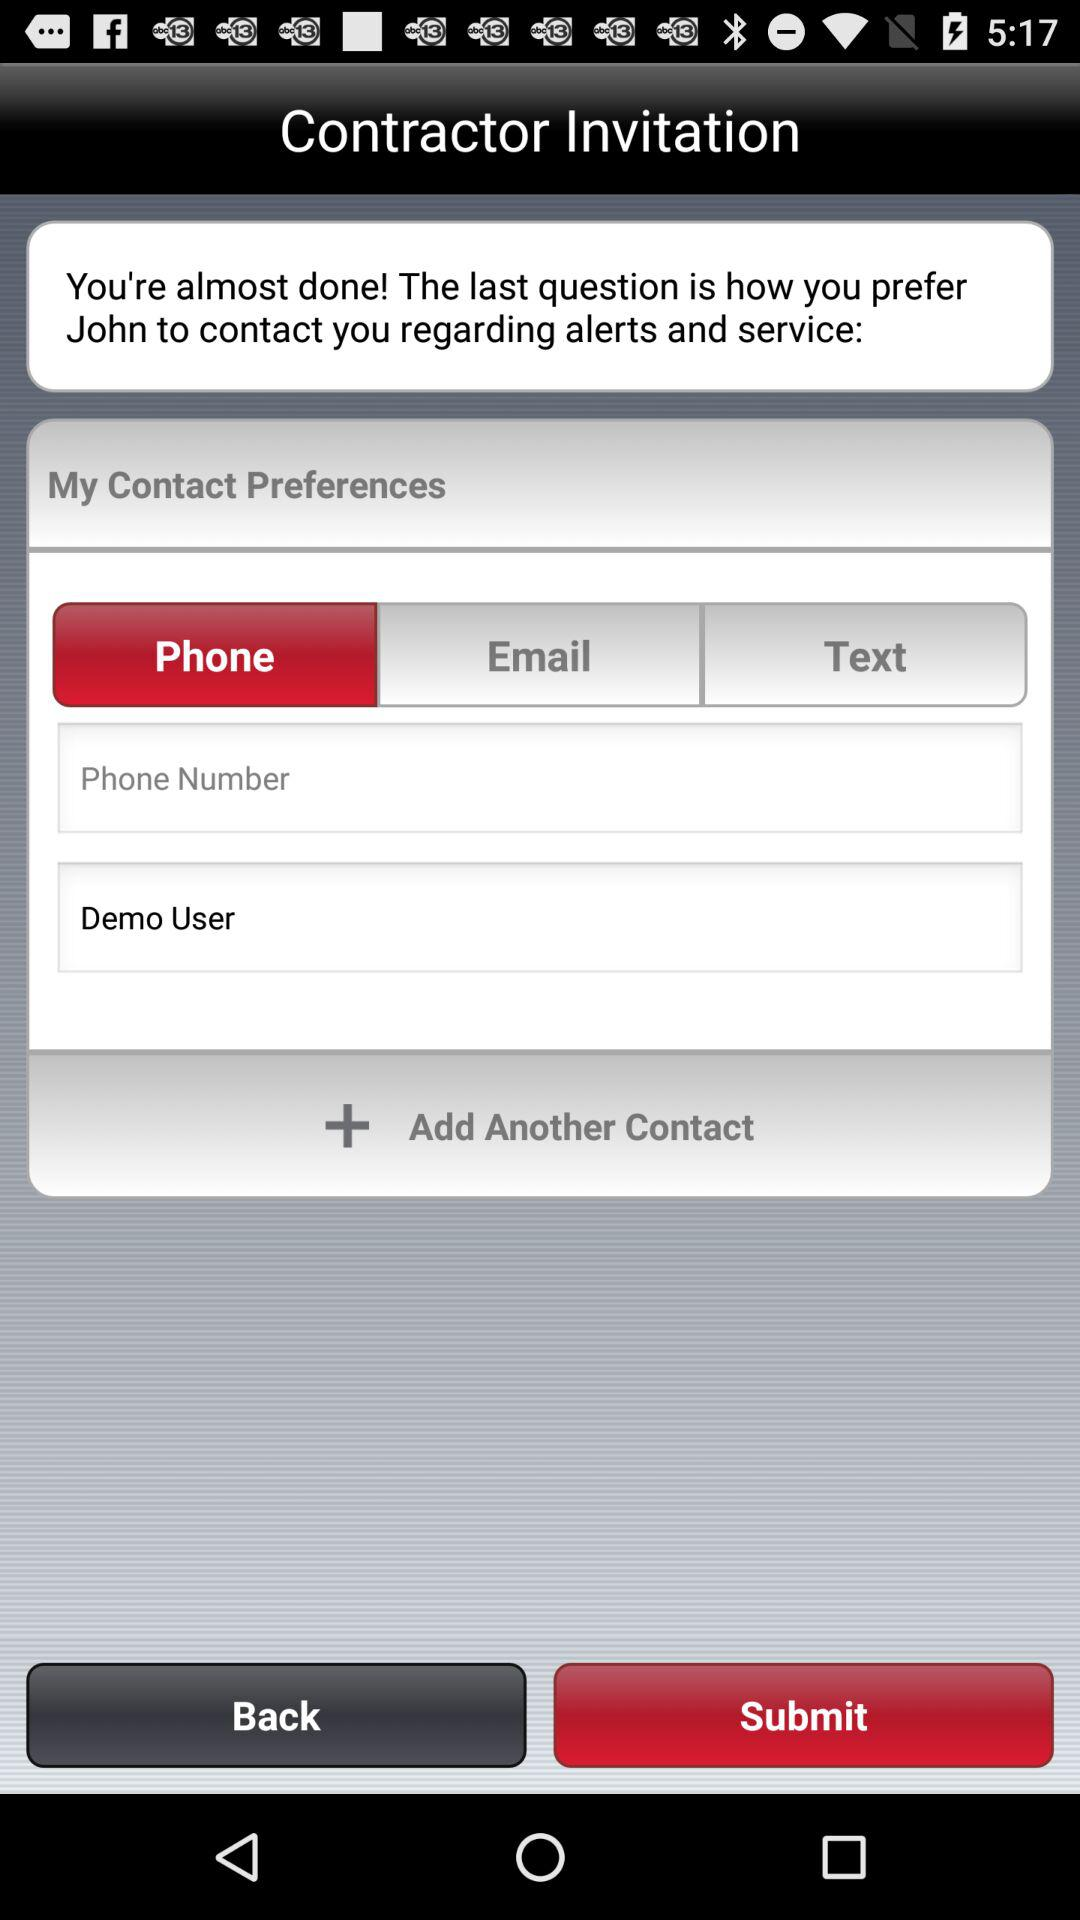Which tab is selected? The selected tab is "Phone". 